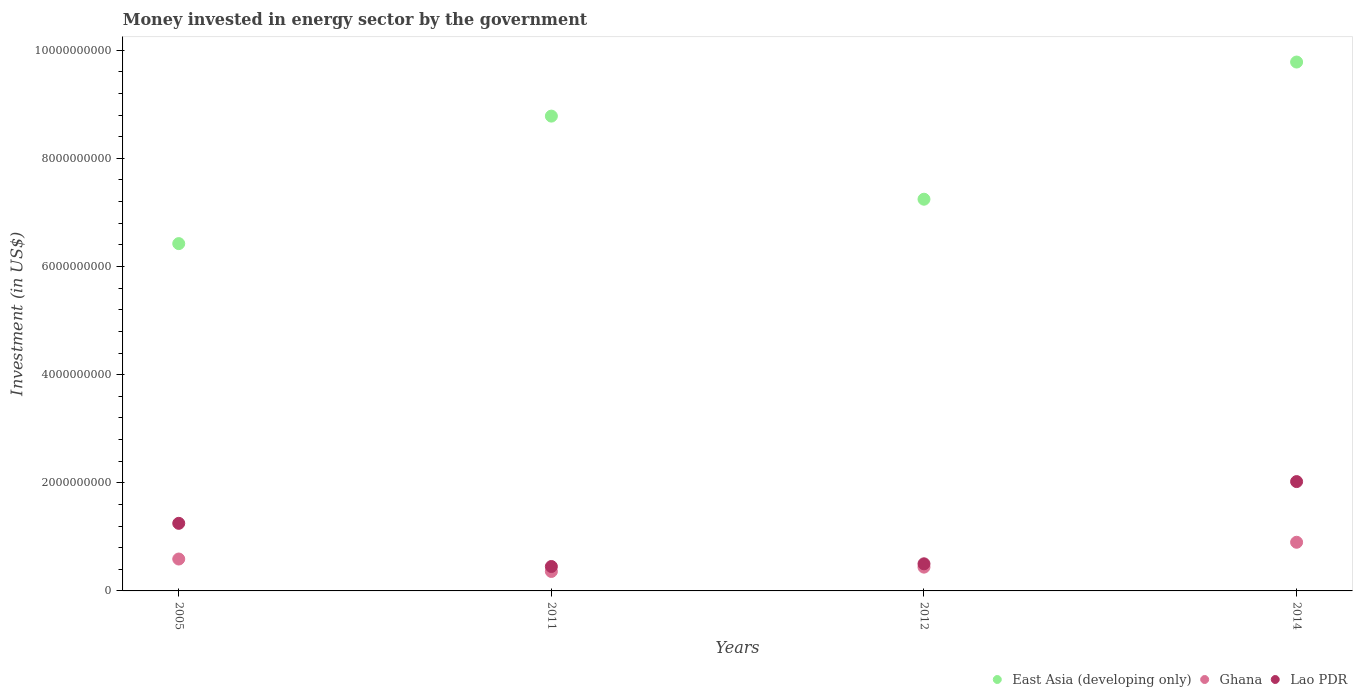Is the number of dotlines equal to the number of legend labels?
Give a very brief answer. Yes. What is the money spent in energy sector in East Asia (developing only) in 2005?
Make the answer very short. 6.42e+09. Across all years, what is the maximum money spent in energy sector in East Asia (developing only)?
Your answer should be very brief. 9.78e+09. Across all years, what is the minimum money spent in energy sector in East Asia (developing only)?
Provide a succinct answer. 6.42e+09. What is the total money spent in energy sector in Ghana in the graph?
Offer a terse response. 2.29e+09. What is the difference between the money spent in energy sector in Ghana in 2005 and that in 2012?
Offer a very short reply. 1.50e+08. What is the difference between the money spent in energy sector in Ghana in 2011 and the money spent in energy sector in East Asia (developing only) in 2014?
Make the answer very short. -9.42e+09. What is the average money spent in energy sector in East Asia (developing only) per year?
Make the answer very short. 8.06e+09. In the year 2014, what is the difference between the money spent in energy sector in East Asia (developing only) and money spent in energy sector in Ghana?
Provide a succinct answer. 8.88e+09. What is the ratio of the money spent in energy sector in Lao PDR in 2011 to that in 2014?
Ensure brevity in your answer.  0.22. Is the difference between the money spent in energy sector in East Asia (developing only) in 2005 and 2011 greater than the difference between the money spent in energy sector in Ghana in 2005 and 2011?
Provide a short and direct response. No. What is the difference between the highest and the second highest money spent in energy sector in Lao PDR?
Make the answer very short. 7.72e+08. What is the difference between the highest and the lowest money spent in energy sector in East Asia (developing only)?
Provide a short and direct response. 3.36e+09. In how many years, is the money spent in energy sector in Lao PDR greater than the average money spent in energy sector in Lao PDR taken over all years?
Your answer should be compact. 2. Is the sum of the money spent in energy sector in East Asia (developing only) in 2011 and 2012 greater than the maximum money spent in energy sector in Ghana across all years?
Provide a short and direct response. Yes. Does the money spent in energy sector in Ghana monotonically increase over the years?
Your answer should be compact. No. Is the money spent in energy sector in Lao PDR strictly less than the money spent in energy sector in East Asia (developing only) over the years?
Offer a terse response. Yes. How many dotlines are there?
Give a very brief answer. 3. What is the difference between two consecutive major ticks on the Y-axis?
Your response must be concise. 2.00e+09. Where does the legend appear in the graph?
Offer a very short reply. Bottom right. How are the legend labels stacked?
Provide a succinct answer. Horizontal. What is the title of the graph?
Provide a succinct answer. Money invested in energy sector by the government. Does "Congo (Democratic)" appear as one of the legend labels in the graph?
Provide a succinct answer. No. What is the label or title of the Y-axis?
Your answer should be very brief. Investment (in US$). What is the Investment (in US$) in East Asia (developing only) in 2005?
Your response must be concise. 6.42e+09. What is the Investment (in US$) of Ghana in 2005?
Make the answer very short. 5.90e+08. What is the Investment (in US$) of Lao PDR in 2005?
Provide a succinct answer. 1.25e+09. What is the Investment (in US$) of East Asia (developing only) in 2011?
Provide a succinct answer. 8.78e+09. What is the Investment (in US$) of Ghana in 2011?
Ensure brevity in your answer.  3.60e+08. What is the Investment (in US$) of Lao PDR in 2011?
Keep it short and to the point. 4.52e+08. What is the Investment (in US$) of East Asia (developing only) in 2012?
Offer a terse response. 7.24e+09. What is the Investment (in US$) in Ghana in 2012?
Your response must be concise. 4.40e+08. What is the Investment (in US$) in Lao PDR in 2012?
Offer a very short reply. 5.01e+08. What is the Investment (in US$) of East Asia (developing only) in 2014?
Ensure brevity in your answer.  9.78e+09. What is the Investment (in US$) in Ghana in 2014?
Your response must be concise. 9.00e+08. What is the Investment (in US$) in Lao PDR in 2014?
Offer a very short reply. 2.02e+09. Across all years, what is the maximum Investment (in US$) in East Asia (developing only)?
Your answer should be compact. 9.78e+09. Across all years, what is the maximum Investment (in US$) of Ghana?
Provide a succinct answer. 9.00e+08. Across all years, what is the maximum Investment (in US$) of Lao PDR?
Keep it short and to the point. 2.02e+09. Across all years, what is the minimum Investment (in US$) of East Asia (developing only)?
Ensure brevity in your answer.  6.42e+09. Across all years, what is the minimum Investment (in US$) in Ghana?
Give a very brief answer. 3.60e+08. Across all years, what is the minimum Investment (in US$) in Lao PDR?
Make the answer very short. 4.52e+08. What is the total Investment (in US$) of East Asia (developing only) in the graph?
Give a very brief answer. 3.22e+1. What is the total Investment (in US$) in Ghana in the graph?
Provide a succinct answer. 2.29e+09. What is the total Investment (in US$) in Lao PDR in the graph?
Offer a terse response. 4.23e+09. What is the difference between the Investment (in US$) in East Asia (developing only) in 2005 and that in 2011?
Keep it short and to the point. -2.36e+09. What is the difference between the Investment (in US$) in Ghana in 2005 and that in 2011?
Your answer should be compact. 2.30e+08. What is the difference between the Investment (in US$) in Lao PDR in 2005 and that in 2011?
Keep it short and to the point. 7.98e+08. What is the difference between the Investment (in US$) of East Asia (developing only) in 2005 and that in 2012?
Give a very brief answer. -8.21e+08. What is the difference between the Investment (in US$) in Ghana in 2005 and that in 2012?
Make the answer very short. 1.50e+08. What is the difference between the Investment (in US$) of Lao PDR in 2005 and that in 2012?
Ensure brevity in your answer.  7.49e+08. What is the difference between the Investment (in US$) of East Asia (developing only) in 2005 and that in 2014?
Keep it short and to the point. -3.36e+09. What is the difference between the Investment (in US$) of Ghana in 2005 and that in 2014?
Offer a very short reply. -3.10e+08. What is the difference between the Investment (in US$) of Lao PDR in 2005 and that in 2014?
Your answer should be very brief. -7.72e+08. What is the difference between the Investment (in US$) in East Asia (developing only) in 2011 and that in 2012?
Provide a succinct answer. 1.54e+09. What is the difference between the Investment (in US$) of Ghana in 2011 and that in 2012?
Provide a succinct answer. -8.00e+07. What is the difference between the Investment (in US$) of Lao PDR in 2011 and that in 2012?
Keep it short and to the point. -4.98e+07. What is the difference between the Investment (in US$) in East Asia (developing only) in 2011 and that in 2014?
Give a very brief answer. -1.00e+09. What is the difference between the Investment (in US$) of Ghana in 2011 and that in 2014?
Your response must be concise. -5.40e+08. What is the difference between the Investment (in US$) in Lao PDR in 2011 and that in 2014?
Make the answer very short. -1.57e+09. What is the difference between the Investment (in US$) in East Asia (developing only) in 2012 and that in 2014?
Your answer should be very brief. -2.54e+09. What is the difference between the Investment (in US$) of Ghana in 2012 and that in 2014?
Your answer should be compact. -4.60e+08. What is the difference between the Investment (in US$) in Lao PDR in 2012 and that in 2014?
Your answer should be very brief. -1.52e+09. What is the difference between the Investment (in US$) in East Asia (developing only) in 2005 and the Investment (in US$) in Ghana in 2011?
Your answer should be compact. 6.06e+09. What is the difference between the Investment (in US$) of East Asia (developing only) in 2005 and the Investment (in US$) of Lao PDR in 2011?
Your answer should be compact. 5.97e+09. What is the difference between the Investment (in US$) in Ghana in 2005 and the Investment (in US$) in Lao PDR in 2011?
Make the answer very short. 1.38e+08. What is the difference between the Investment (in US$) in East Asia (developing only) in 2005 and the Investment (in US$) in Ghana in 2012?
Make the answer very short. 5.98e+09. What is the difference between the Investment (in US$) in East Asia (developing only) in 2005 and the Investment (in US$) in Lao PDR in 2012?
Provide a succinct answer. 5.92e+09. What is the difference between the Investment (in US$) of Ghana in 2005 and the Investment (in US$) of Lao PDR in 2012?
Ensure brevity in your answer.  8.86e+07. What is the difference between the Investment (in US$) in East Asia (developing only) in 2005 and the Investment (in US$) in Ghana in 2014?
Offer a terse response. 5.52e+09. What is the difference between the Investment (in US$) in East Asia (developing only) in 2005 and the Investment (in US$) in Lao PDR in 2014?
Your response must be concise. 4.40e+09. What is the difference between the Investment (in US$) of Ghana in 2005 and the Investment (in US$) of Lao PDR in 2014?
Ensure brevity in your answer.  -1.43e+09. What is the difference between the Investment (in US$) of East Asia (developing only) in 2011 and the Investment (in US$) of Ghana in 2012?
Your answer should be very brief. 8.34e+09. What is the difference between the Investment (in US$) in East Asia (developing only) in 2011 and the Investment (in US$) in Lao PDR in 2012?
Your answer should be compact. 8.28e+09. What is the difference between the Investment (in US$) of Ghana in 2011 and the Investment (in US$) of Lao PDR in 2012?
Make the answer very short. -1.41e+08. What is the difference between the Investment (in US$) in East Asia (developing only) in 2011 and the Investment (in US$) in Ghana in 2014?
Provide a succinct answer. 7.88e+09. What is the difference between the Investment (in US$) in East Asia (developing only) in 2011 and the Investment (in US$) in Lao PDR in 2014?
Make the answer very short. 6.76e+09. What is the difference between the Investment (in US$) of Ghana in 2011 and the Investment (in US$) of Lao PDR in 2014?
Ensure brevity in your answer.  -1.66e+09. What is the difference between the Investment (in US$) in East Asia (developing only) in 2012 and the Investment (in US$) in Ghana in 2014?
Ensure brevity in your answer.  6.34e+09. What is the difference between the Investment (in US$) of East Asia (developing only) in 2012 and the Investment (in US$) of Lao PDR in 2014?
Offer a terse response. 5.22e+09. What is the difference between the Investment (in US$) in Ghana in 2012 and the Investment (in US$) in Lao PDR in 2014?
Make the answer very short. -1.58e+09. What is the average Investment (in US$) in East Asia (developing only) per year?
Keep it short and to the point. 8.06e+09. What is the average Investment (in US$) in Ghana per year?
Give a very brief answer. 5.72e+08. What is the average Investment (in US$) in Lao PDR per year?
Make the answer very short. 1.06e+09. In the year 2005, what is the difference between the Investment (in US$) of East Asia (developing only) and Investment (in US$) of Ghana?
Your answer should be very brief. 5.83e+09. In the year 2005, what is the difference between the Investment (in US$) of East Asia (developing only) and Investment (in US$) of Lao PDR?
Provide a short and direct response. 5.17e+09. In the year 2005, what is the difference between the Investment (in US$) of Ghana and Investment (in US$) of Lao PDR?
Your answer should be compact. -6.60e+08. In the year 2011, what is the difference between the Investment (in US$) of East Asia (developing only) and Investment (in US$) of Ghana?
Offer a terse response. 8.42e+09. In the year 2011, what is the difference between the Investment (in US$) of East Asia (developing only) and Investment (in US$) of Lao PDR?
Provide a short and direct response. 8.33e+09. In the year 2011, what is the difference between the Investment (in US$) in Ghana and Investment (in US$) in Lao PDR?
Your answer should be very brief. -9.16e+07. In the year 2012, what is the difference between the Investment (in US$) in East Asia (developing only) and Investment (in US$) in Ghana?
Make the answer very short. 6.80e+09. In the year 2012, what is the difference between the Investment (in US$) of East Asia (developing only) and Investment (in US$) of Lao PDR?
Make the answer very short. 6.74e+09. In the year 2012, what is the difference between the Investment (in US$) in Ghana and Investment (in US$) in Lao PDR?
Offer a very short reply. -6.14e+07. In the year 2014, what is the difference between the Investment (in US$) of East Asia (developing only) and Investment (in US$) of Ghana?
Offer a terse response. 8.88e+09. In the year 2014, what is the difference between the Investment (in US$) in East Asia (developing only) and Investment (in US$) in Lao PDR?
Provide a succinct answer. 7.76e+09. In the year 2014, what is the difference between the Investment (in US$) of Ghana and Investment (in US$) of Lao PDR?
Provide a short and direct response. -1.12e+09. What is the ratio of the Investment (in US$) of East Asia (developing only) in 2005 to that in 2011?
Your response must be concise. 0.73. What is the ratio of the Investment (in US$) of Ghana in 2005 to that in 2011?
Offer a terse response. 1.64. What is the ratio of the Investment (in US$) of Lao PDR in 2005 to that in 2011?
Keep it short and to the point. 2.77. What is the ratio of the Investment (in US$) in East Asia (developing only) in 2005 to that in 2012?
Keep it short and to the point. 0.89. What is the ratio of the Investment (in US$) in Ghana in 2005 to that in 2012?
Your answer should be compact. 1.34. What is the ratio of the Investment (in US$) in Lao PDR in 2005 to that in 2012?
Offer a very short reply. 2.49. What is the ratio of the Investment (in US$) in East Asia (developing only) in 2005 to that in 2014?
Your answer should be compact. 0.66. What is the ratio of the Investment (in US$) in Ghana in 2005 to that in 2014?
Provide a succinct answer. 0.66. What is the ratio of the Investment (in US$) of Lao PDR in 2005 to that in 2014?
Provide a succinct answer. 0.62. What is the ratio of the Investment (in US$) of East Asia (developing only) in 2011 to that in 2012?
Your answer should be very brief. 1.21. What is the ratio of the Investment (in US$) in Ghana in 2011 to that in 2012?
Your answer should be compact. 0.82. What is the ratio of the Investment (in US$) of Lao PDR in 2011 to that in 2012?
Make the answer very short. 0.9. What is the ratio of the Investment (in US$) of East Asia (developing only) in 2011 to that in 2014?
Your response must be concise. 0.9. What is the ratio of the Investment (in US$) of Lao PDR in 2011 to that in 2014?
Give a very brief answer. 0.22. What is the ratio of the Investment (in US$) in East Asia (developing only) in 2012 to that in 2014?
Provide a succinct answer. 0.74. What is the ratio of the Investment (in US$) of Ghana in 2012 to that in 2014?
Offer a terse response. 0.49. What is the ratio of the Investment (in US$) in Lao PDR in 2012 to that in 2014?
Offer a very short reply. 0.25. What is the difference between the highest and the second highest Investment (in US$) of East Asia (developing only)?
Make the answer very short. 1.00e+09. What is the difference between the highest and the second highest Investment (in US$) of Ghana?
Your answer should be compact. 3.10e+08. What is the difference between the highest and the second highest Investment (in US$) of Lao PDR?
Make the answer very short. 7.72e+08. What is the difference between the highest and the lowest Investment (in US$) in East Asia (developing only)?
Give a very brief answer. 3.36e+09. What is the difference between the highest and the lowest Investment (in US$) of Ghana?
Keep it short and to the point. 5.40e+08. What is the difference between the highest and the lowest Investment (in US$) of Lao PDR?
Your answer should be compact. 1.57e+09. 